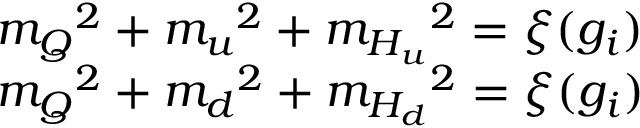Convert formula to latex. <formula><loc_0><loc_0><loc_500><loc_500>\begin{array} { l } { { { m _ { Q } } ^ { 2 } + { m _ { u } } ^ { 2 } + { m _ { H _ { u } } } ^ { 2 } = \xi ( { g _ { i } } ) } } \\ { { { m _ { Q } } ^ { 2 } + { m _ { d } } ^ { 2 } + { m _ { H _ { d } } } ^ { 2 } = \xi ( { g _ { i } } ) } } \end{array}</formula> 